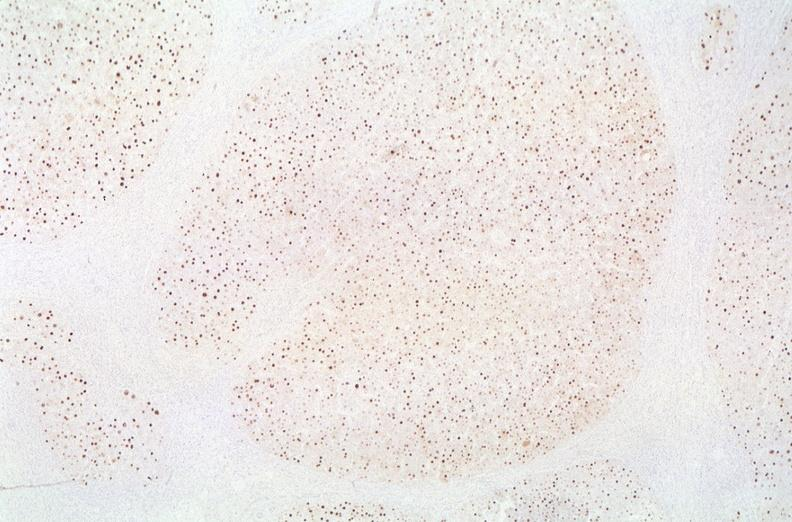does this image show hepatitis b virus, hbve antigen immunohistochemistry?
Answer the question using a single word or phrase. Yes 